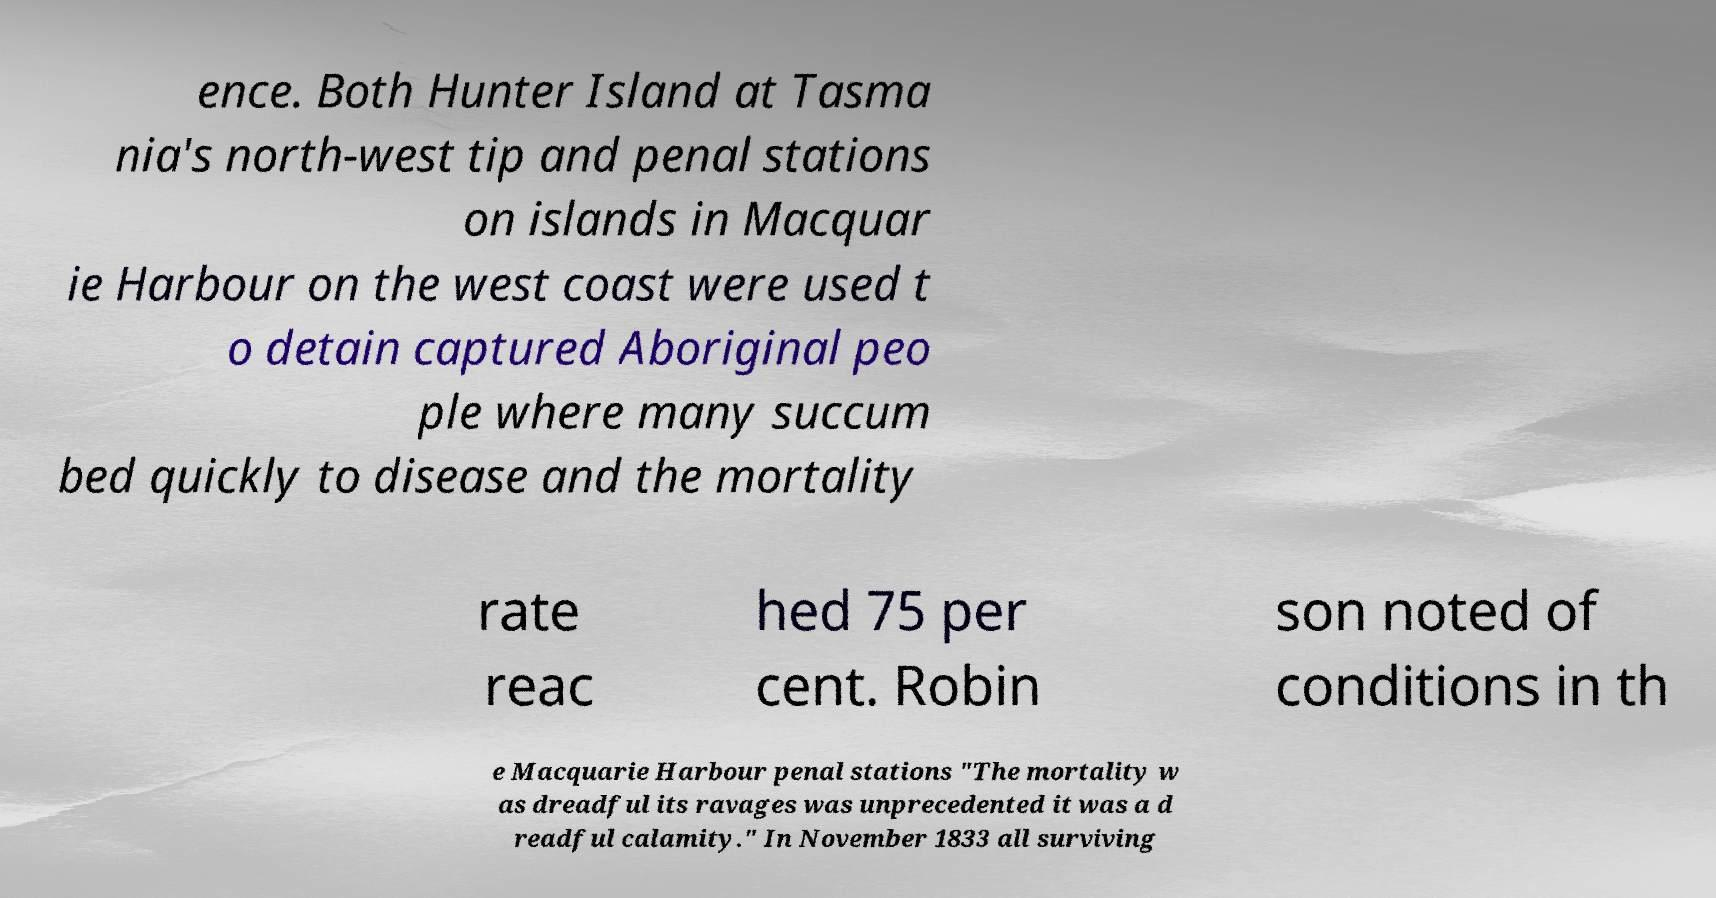There's text embedded in this image that I need extracted. Can you transcribe it verbatim? ence. Both Hunter Island at Tasma nia's north-west tip and penal stations on islands in Macquar ie Harbour on the west coast were used t o detain captured Aboriginal peo ple where many succum bed quickly to disease and the mortality rate reac hed 75 per cent. Robin son noted of conditions in th e Macquarie Harbour penal stations "The mortality w as dreadful its ravages was unprecedented it was a d readful calamity." In November 1833 all surviving 